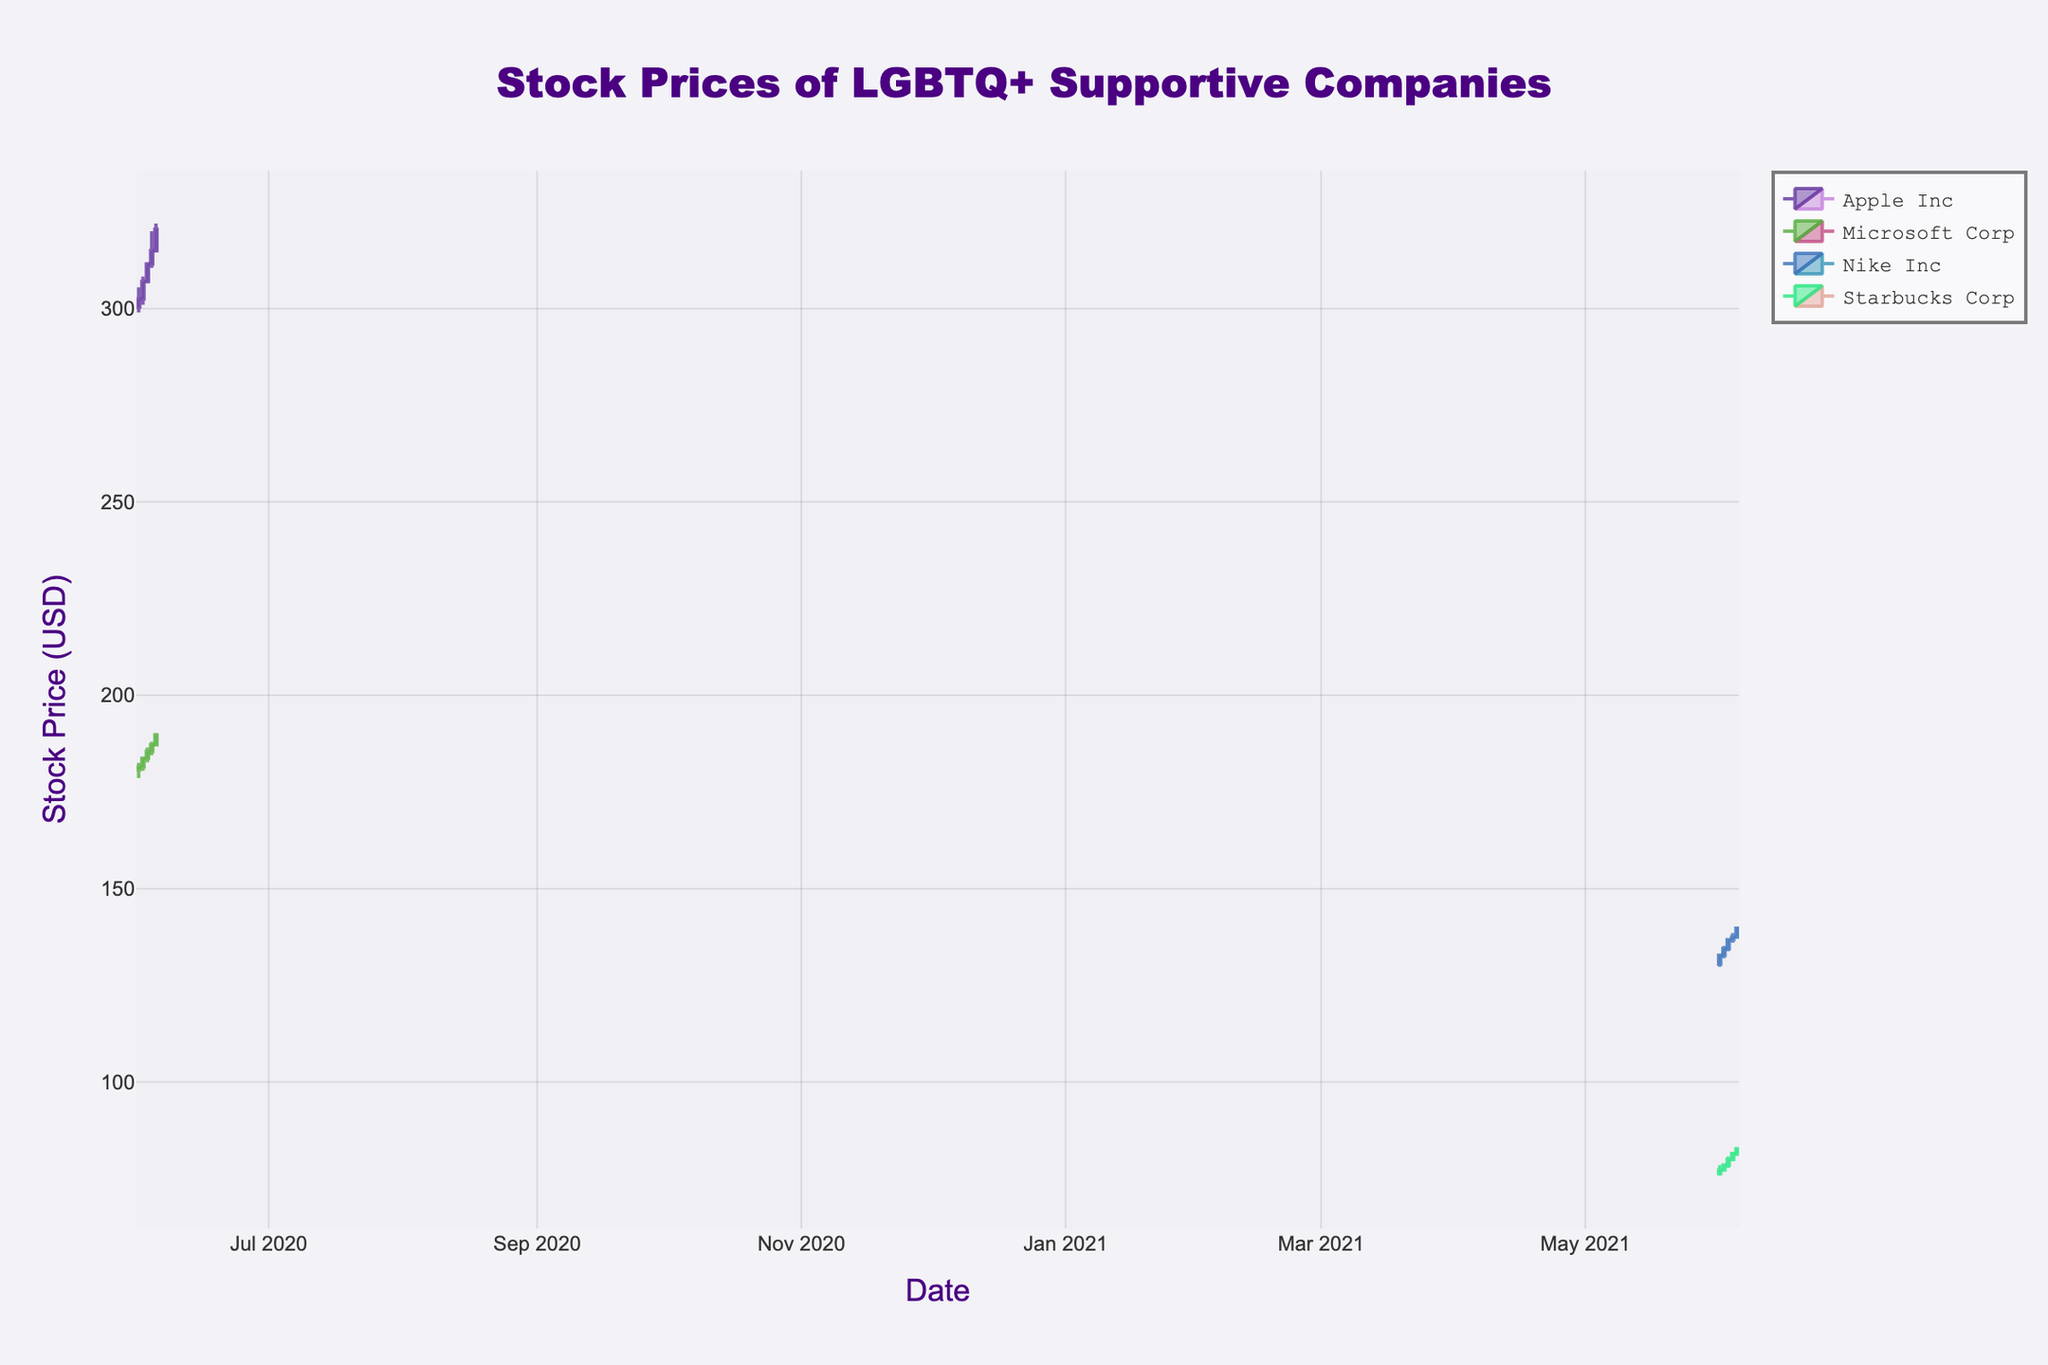What is the title of the figure? The title of the figure is displayed prominently at the top. The large font and positioning make it easily noticeable amidst other elements.
Answer: Stock Prices of LGBTQ+ Supportive Companies Which company has the highest closing stock price on June 5, 2020? To find the highest closing stock price on June 5, 2020, look for the closing prices of Apple Inc and Microsoft Corp on that date and compare them. Apple Inc has a closing price of 320.50, while Microsoft Corp has a closing price of 189.75.
Answer: Apple Inc How many companies' stock prices are shown in the figure? The figure contains candlestick traces for each company. Identify the unique companies listed: Apple Inc, Microsoft Corp, Nike Inc, and Starbucks Corp. Count the number of unique company names to get the answer.
Answer: 4 What was the average closing price of Nike Inc from June 1 to June 5, 2021? To find the average closing price, sum the closing prices of Nike Inc from June 1 to June 5, 2021 (132.75 + 134.50 + 136.80 + 137.50 + 139.75) and divide by the total number of days (5).  Sums up to 681.30; dividing 681.30 by 5 gives 136.26.
Answer: 136.26 Did Starbucks Corp's stock trend upwards or downwards from June 1 to June 5, 2021? To determine the trend, compare the closing prices of Starbucks Corp on June 1 (77.25) and June 5 (82.75). A higher closing price on June 5 indicates an upward trend.
Answer: Upwards Which day had the highest trading volume for Apple Inc? To identify the day with the highest trading volume for Apple Inc, examine the volumes for each day and find the maximum value. The highest volume is 51,200,000 on June 5, 2020.
Answer: June 5, 2020 By how much did the closing price of Microsoft Corp increase from June 1 to June 5, 2020? Calculate the difference between the closing prices on June 5, 2020 (189.75), and June 1, 2020 (181.50) to find the change in closing price. 189.75 - 181.50 = 8.25.
Answer: 8.25 Which company showed the most consistent upward trend in stock prices during their respective dates? Identify the price pattern for each company by examining the closing prices over the respective date ranges. Nike Inc's closing prices continuously increase from June 1 to June 5, 2021, indicating the most consistent upward trend.
Answer: Nike Inc How does the volume of trades for Starbucks Corp on June 3, 2021, compare to that on June 4, 2021? Compare the trading volumes of Starbucks Corp on June 3, 2021 (27,570,000), and June 4, 2021 (28,240,000). The higher volume on June 4 suggests an increase in trading activity.
Answer: Increased 